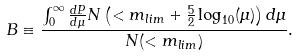Convert formula to latex. <formula><loc_0><loc_0><loc_500><loc_500>B \equiv \frac { \int _ { 0 } ^ { \infty } \frac { d P } { d \mu } N \left ( < m _ { l i m } + \frac { 5 } { 2 } \log _ { 1 0 } ( \mu ) \right ) d \mu } { N ( < m _ { l i m } ) } .</formula> 